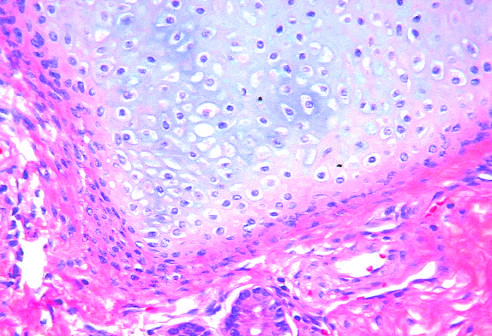do granulocytic forms at various stages of differentiation contain mature cells from endodermal, mesodermal, and ectodermal lines?
Answer the question using a single word or phrase. No 